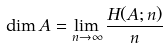<formula> <loc_0><loc_0><loc_500><loc_500>\dim A = \lim _ { n \to \infty } \frac { H ( A ; n ) } { n }</formula> 